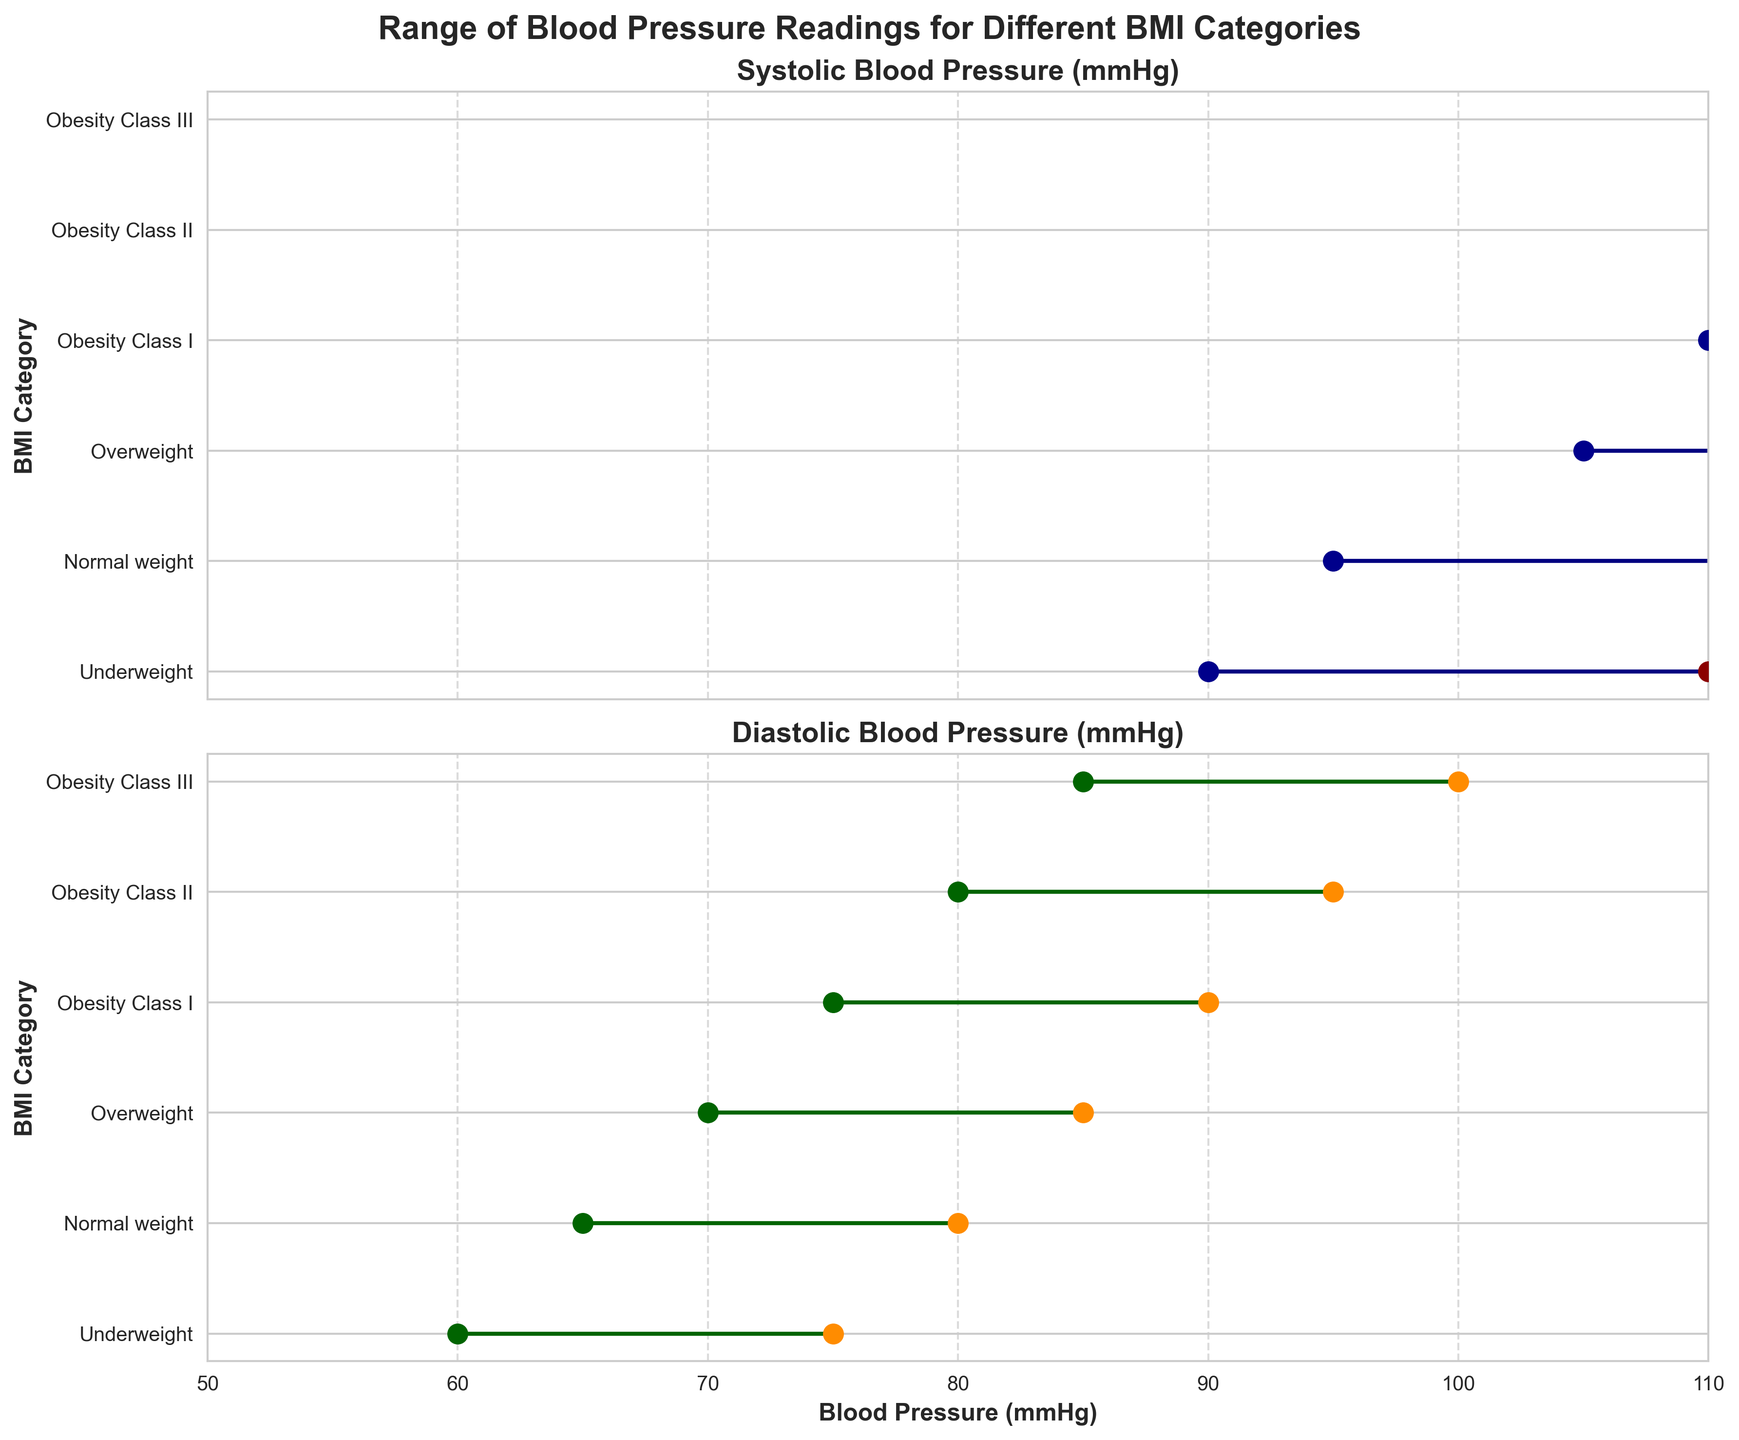What is the minimum systolic blood pressure for the 'Overweight' BMI category? The minimum systolic blood pressure values can be found by looking at the dark blue dots on the Systolic Blood Pressure plot. For the 'Overweight' category, this value is 105 mmHg.
Answer: 105 What is the range of diastolic blood pressure for the 'Obesity Class III' category? The range of diastolic blood pressure is the difference between the maximum and minimum diastolic values. For 'Obesity Class III', the range is 100 - 85 = 15 mmHg.
Answer: 15 Which BMI category has the highest maximum systolic blood pressure? By comparing the rightmost dark red dots on the Systolic Blood Pressure plot, 'Obesity Class III' has the highest maximum systolic blood pressure of 160 mmHg.
Answer: Obesity Class III Which has a greater range in diastolic blood pressure: 'Underweight' or 'Normal weight'? The range of diastolic blood pressure for 'Underweight' is 75 - 60 = 15 mmHg, and for 'Normal weight', it is 80 - 65 = 15 mmHg. Both categories have the same range of 15 mmHg.
Answer: Both What is the difference between the maximum systolic blood pressure in the 'Normal weight' and 'Obesity Class II' categories? The maximum systolic blood pressure for 'Normal weight' is 120 mmHg and for 'Obesity Class II' it is 150 mmHg. The difference is 150 - 120 = 30 mmHg.
Answer: 30 Which BMI category has the smallest range in systolic blood pressure? By comparing the lengths of the horizontal lines in the Systolic Blood Pressure plot, 'Underweight' has the smallest range, from 90 to 110 mmHg, which is a range of 20 mmHg.
Answer: Underweight What is the average of the minimum systolic blood pressure values across all BMI categories? The minimum systolic blood pressure values are 90, 95, 105, 110, 115, and 120 mmHg. The sum is 90 + 95 + 105 + 110 + 115 + 120 = 635. The average is 635 / 6 = 105.83 mmHg.
Answer: 105.83 How does the range of systolic blood pressure in 'Obesity Class I' compare with 'Obesity Class II'? The range for 'Obesity Class I' is 140 - 110 = 30 mmHg, and for 'Obesity Class II' it is 150 - 115 = 35 mmHg. 'Obesity Class II' has a greater range by 5 mmHg.
Answer: Obesity Class II is 5 mmHg greater What is the total range of diastolic blood pressure values across all BMI categories? The total range is found by subtracting the minimum diastolic value from the lowest category (60 mmHg in 'Underweight') from the maximum diastolic value in the highest category (100 mmHg in 'Obesity Class III'). The range is 100 - 60 = 40 mmHg.
Answer: 40 